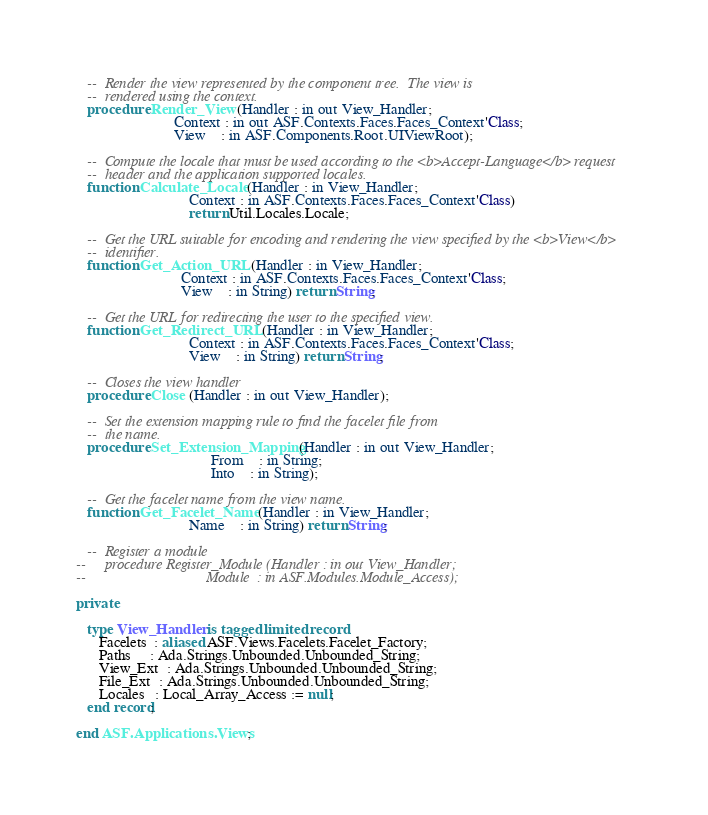Convert code to text. <code><loc_0><loc_0><loc_500><loc_500><_Ada_>
   --  Render the view represented by the component tree.  The view is
   --  rendered using the context.
   procedure Render_View (Handler : in out View_Handler;
                          Context : in out ASF.Contexts.Faces.Faces_Context'Class;
                          View    : in ASF.Components.Root.UIViewRoot);

   --  Compute the locale that must be used according to the <b>Accept-Language</b> request
   --  header and the application supported locales.
   function Calculate_Locale (Handler : in View_Handler;
                              Context : in ASF.Contexts.Faces.Faces_Context'Class)
                              return Util.Locales.Locale;

   --  Get the URL suitable for encoding and rendering the view specified by the <b>View</b>
   --  identifier.
   function Get_Action_URL (Handler : in View_Handler;
                            Context : in ASF.Contexts.Faces.Faces_Context'Class;
                            View    : in String) return String;

   --  Get the URL for redirecting the user to the specified view.
   function Get_Redirect_URL (Handler : in View_Handler;
                              Context : in ASF.Contexts.Faces.Faces_Context'Class;
                              View    : in String) return String;

   --  Closes the view handler
   procedure Close (Handler : in out View_Handler);

   --  Set the extension mapping rule to find the facelet file from
   --  the name.
   procedure Set_Extension_Mapping (Handler : in out View_Handler;
                                    From    : in String;
                                    Into    : in String);

   --  Get the facelet name from the view name.
   function Get_Facelet_Name (Handler : in View_Handler;
                              Name    : in String) return String;

   --  Register a module
--     procedure Register_Module (Handler : in out View_Handler;
--                                Module  : in ASF.Modules.Module_Access);

private

   type View_Handler is tagged limited record
      Facelets  : aliased ASF.Views.Facelets.Facelet_Factory;
      Paths     : Ada.Strings.Unbounded.Unbounded_String;
      View_Ext  : Ada.Strings.Unbounded.Unbounded_String;
      File_Ext  : Ada.Strings.Unbounded.Unbounded_String;
      Locales   : Local_Array_Access := null;
   end record;

end ASF.Applications.Views;
</code> 